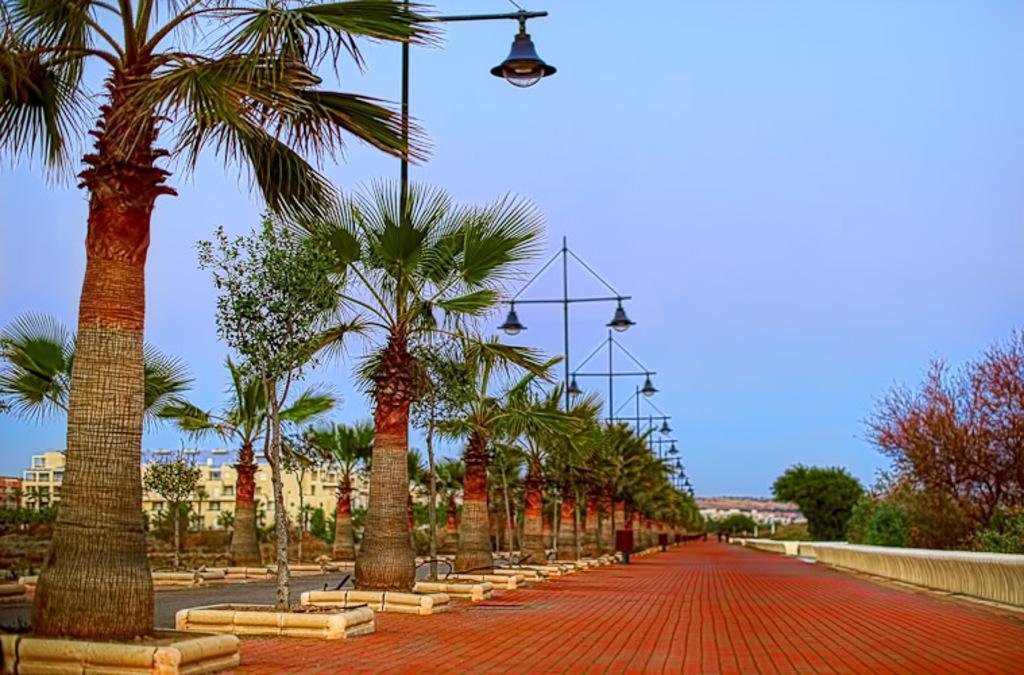In one or two sentences, can you explain what this image depicts? In this image I can see trees in green color, for light poles, at the background I can see building in cream color and sky in blue color. 